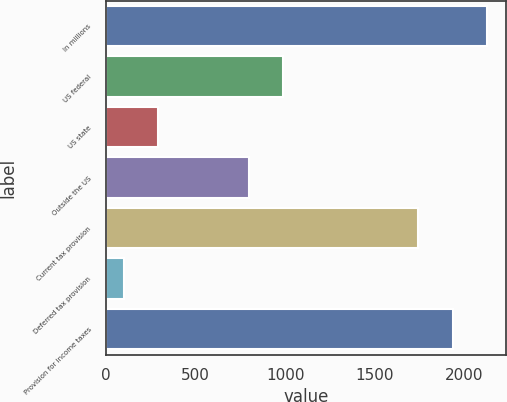<chart> <loc_0><loc_0><loc_500><loc_500><bar_chart><fcel>In millions<fcel>US federal<fcel>US state<fcel>Outside the US<fcel>Current tax provision<fcel>Deferred tax provision<fcel>Provision for income taxes<nl><fcel>2124.6<fcel>990.85<fcel>292.15<fcel>800.2<fcel>1743.3<fcel>101.5<fcel>1933.95<nl></chart> 